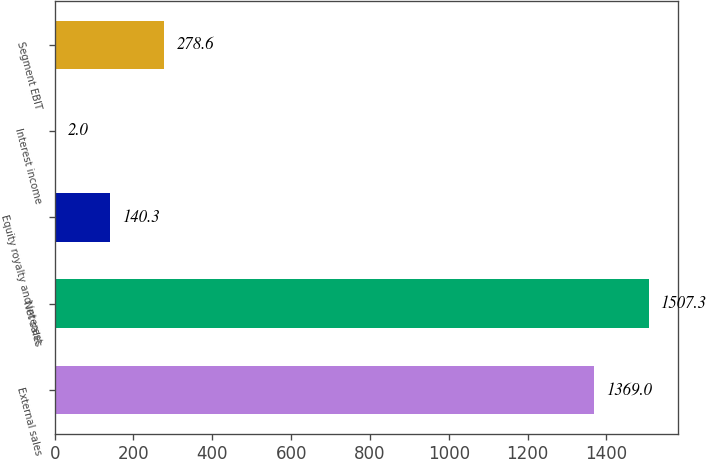Convert chart to OTSL. <chart><loc_0><loc_0><loc_500><loc_500><bar_chart><fcel>External sales<fcel>Net sales<fcel>Equity royalty and interest<fcel>Interest income<fcel>Segment EBIT<nl><fcel>1369<fcel>1507.3<fcel>140.3<fcel>2<fcel>278.6<nl></chart> 